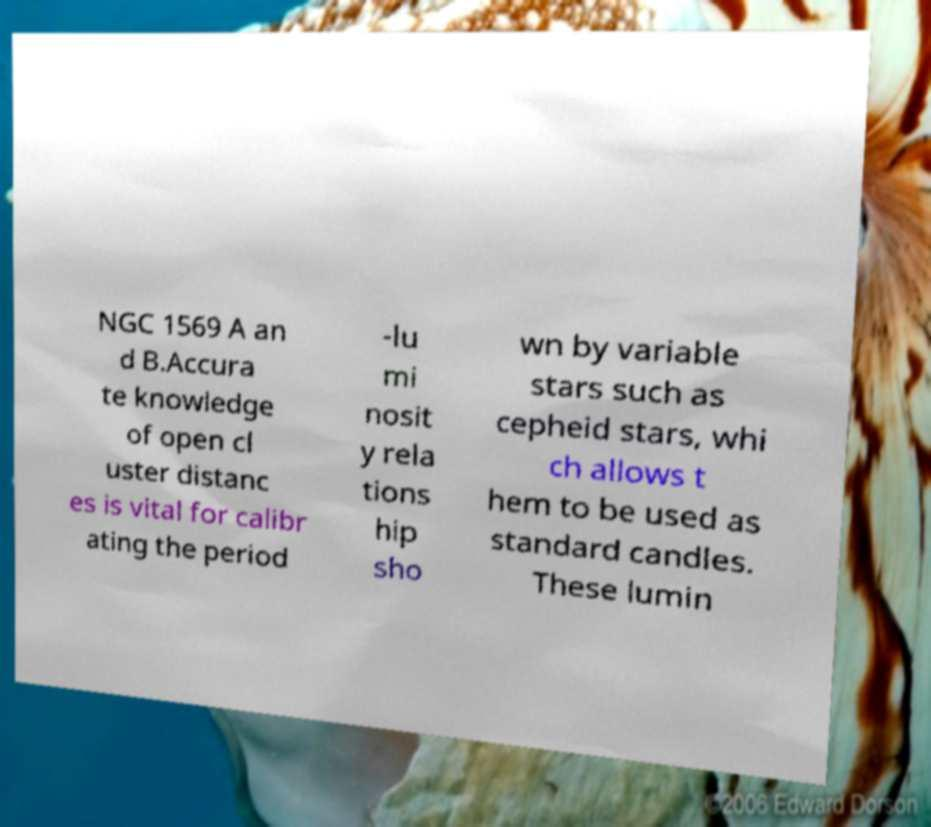Can you read and provide the text displayed in the image?This photo seems to have some interesting text. Can you extract and type it out for me? NGC 1569 A an d B.Accura te knowledge of open cl uster distanc es is vital for calibr ating the period -lu mi nosit y rela tions hip sho wn by variable stars such as cepheid stars, whi ch allows t hem to be used as standard candles. These lumin 